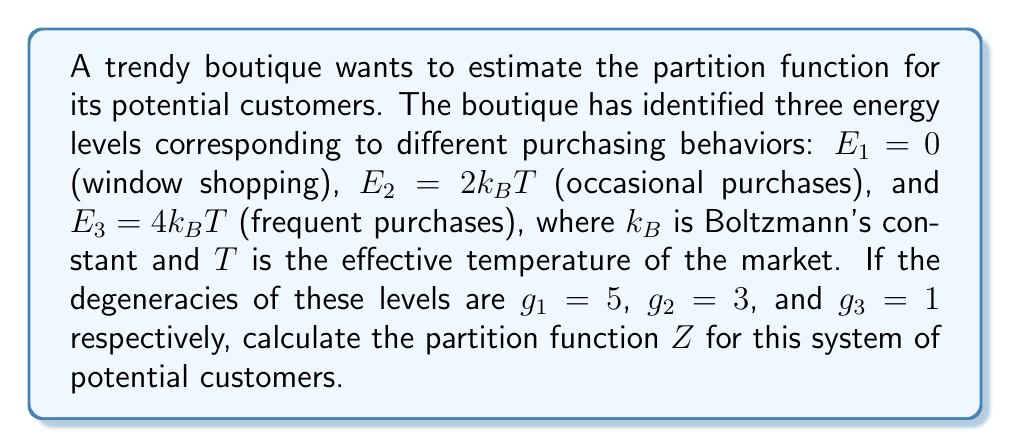What is the answer to this math problem? To calculate the partition function $Z$, we need to sum over all possible energy states, considering their degeneracies. The general form of the partition function is:

$$Z = \sum_i g_i e^{-\beta E_i}$$

where $g_i$ is the degeneracy of state $i$, $E_i$ is the energy of state $i$, and $\beta = \frac{1}{k_BT}$.

Let's calculate each term:

1. For $E_1 = 0$:
   $g_1 e^{-\beta E_1} = 5 e^{-\beta \cdot 0} = 5 \cdot 1 = 5$

2. For $E_2 = 2k_BT$:
   $g_2 e^{-\beta E_2} = 3 e^{-\beta \cdot 2k_BT} = 3 e^{-2} \approx 0.406$

3. For $E_3 = 4k_BT$:
   $g_3 e^{-\beta E_3} = 1 e^{-\beta \cdot 4k_BT} = 1 e^{-4} \approx 0.018$

Now, we sum these terms:

$$Z = 5 + 0.406 + 0.018 \approx 5.424$$
Answer: $Z \approx 5.424$ 